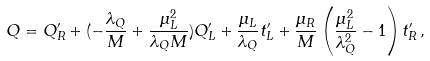<formula> <loc_0><loc_0><loc_500><loc_500>Q = Q _ { R } ^ { \prime } + ( - \frac { \lambda _ { Q } } { M } + \frac { \mu _ { L } ^ { 2 } } { \lambda _ { Q } M } ) Q _ { L } ^ { \prime } + \frac { \mu _ { L } } { \lambda _ { Q } } t _ { L } ^ { \prime } + \frac { \mu _ { R } } { M } \left ( \frac { \mu _ { L } ^ { 2 } } { \lambda _ { Q } ^ { 2 } } - 1 \right ) t _ { R } ^ { \prime } \, ,</formula> 